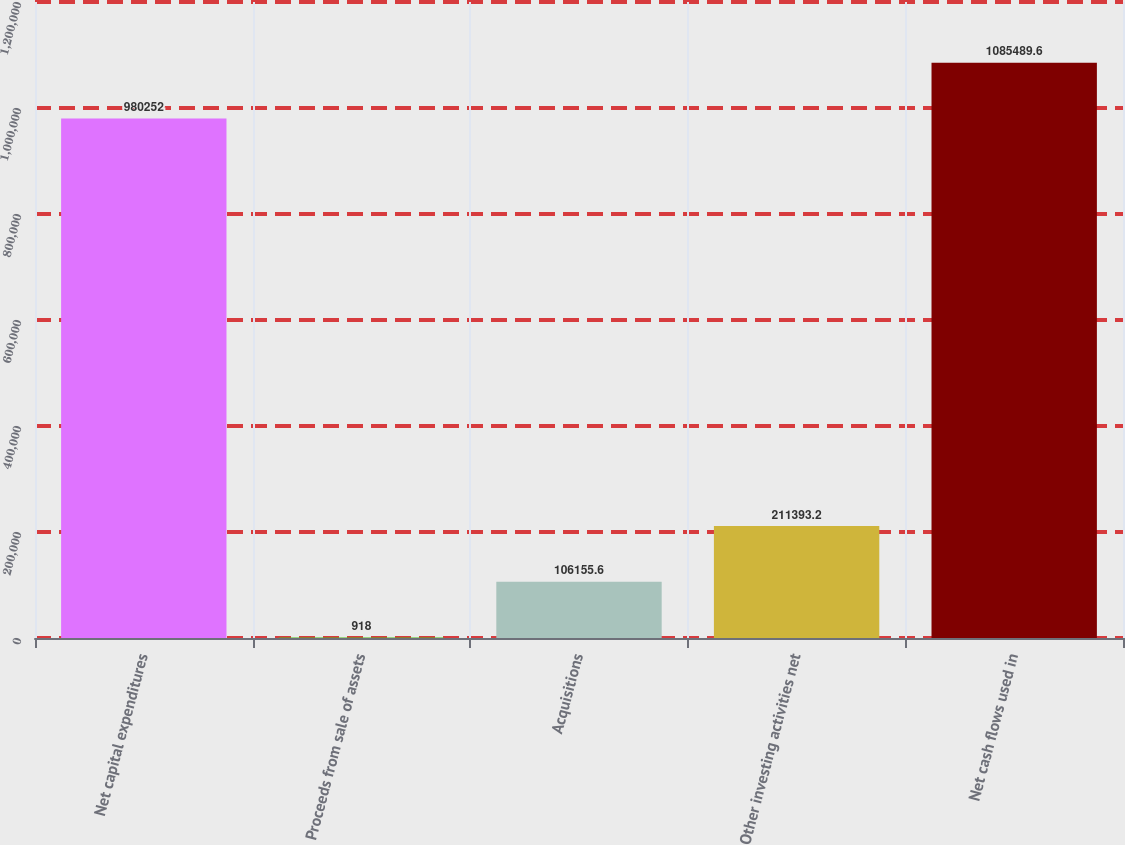<chart> <loc_0><loc_0><loc_500><loc_500><bar_chart><fcel>Net capital expenditures<fcel>Proceeds from sale of assets<fcel>Acquisitions<fcel>Other investing activities net<fcel>Net cash flows used in<nl><fcel>980252<fcel>918<fcel>106156<fcel>211393<fcel>1.08549e+06<nl></chart> 